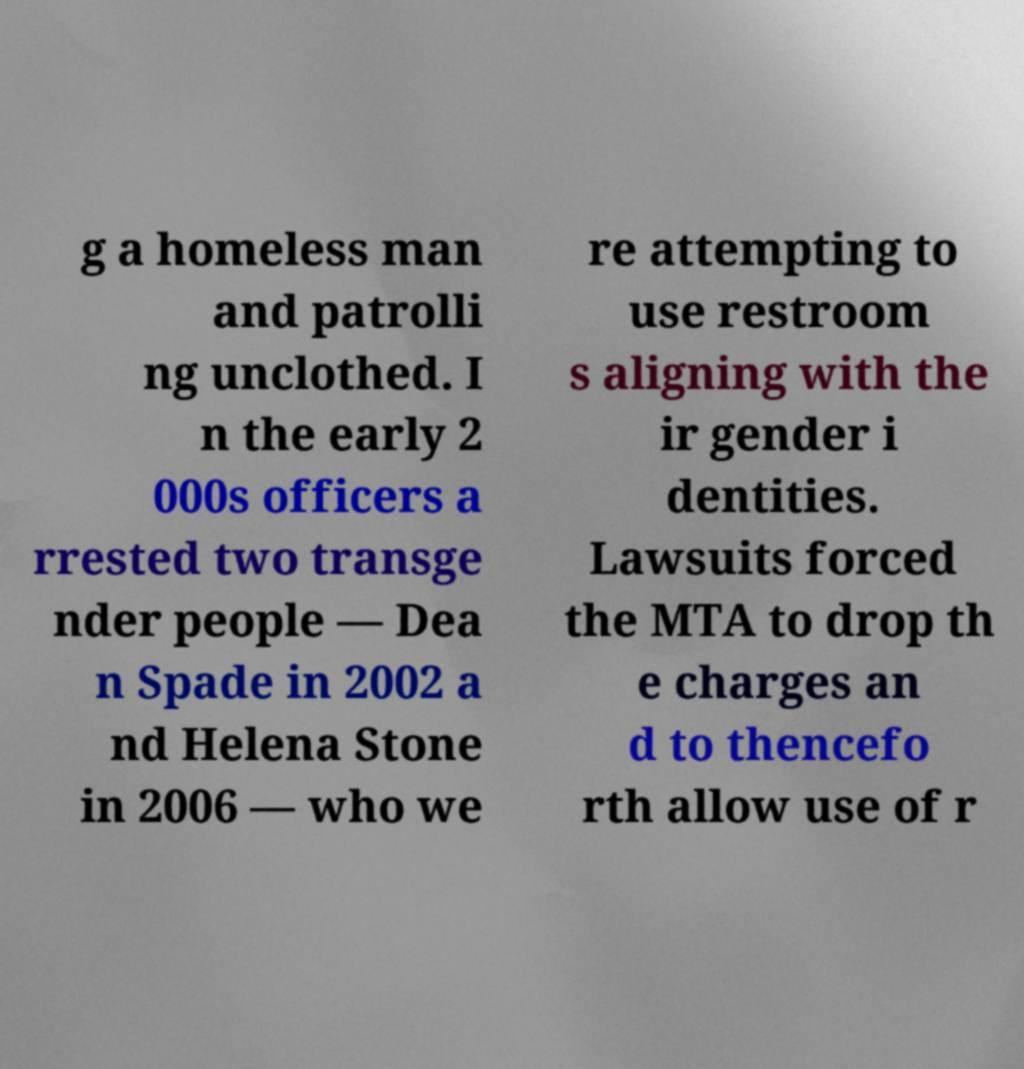For documentation purposes, I need the text within this image transcribed. Could you provide that? g a homeless man and patrolli ng unclothed. I n the early 2 000s officers a rrested two transge nder people — Dea n Spade in 2002 a nd Helena Stone in 2006 — who we re attempting to use restroom s aligning with the ir gender i dentities. Lawsuits forced the MTA to drop th e charges an d to thencefo rth allow use of r 